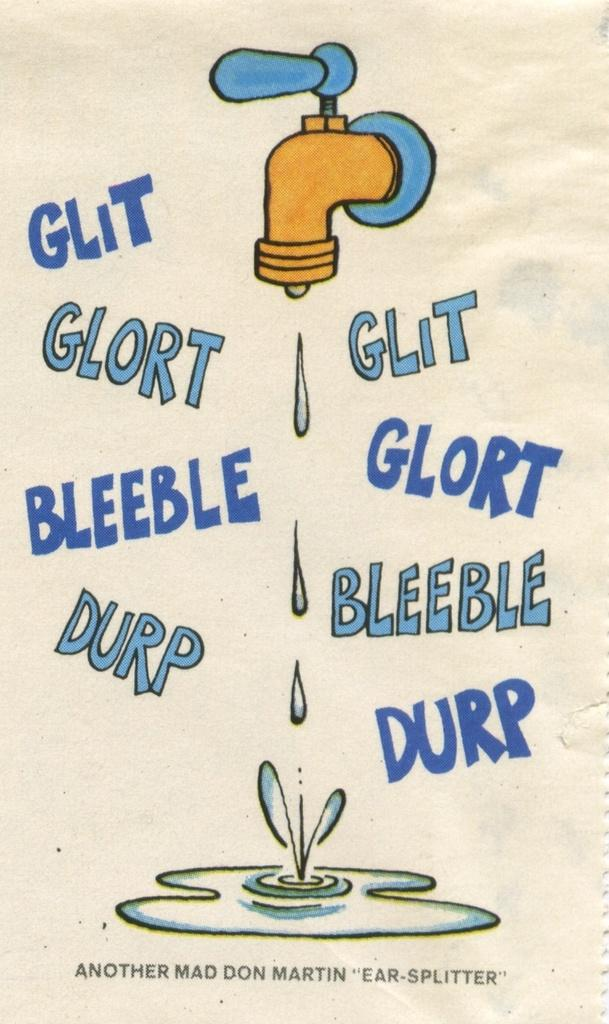<image>
Offer a succinct explanation of the picture presented. Poster illustrating a dripping faucet with words GLORT GLIT BLEEBLE GLORT et cetera under a pool of water. 